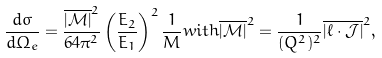<formula> <loc_0><loc_0><loc_500><loc_500>\frac { d \sigma } { d \Omega _ { e } } = \frac { \overline { | { \mathcal { M } } | } ^ { 2 } } { 6 4 \pi ^ { 2 } } \left ( \frac { E _ { 2 } } { E _ { 1 } } \right ) ^ { 2 } \frac { 1 } { M } w i t h \overline { | { \mathcal { M } } | } ^ { 2 } = \frac { 1 } { ( Q ^ { 2 } ) ^ { 2 } } \overline { | \ell \cdot { \mathcal { J } } | } ^ { 2 } ,</formula> 